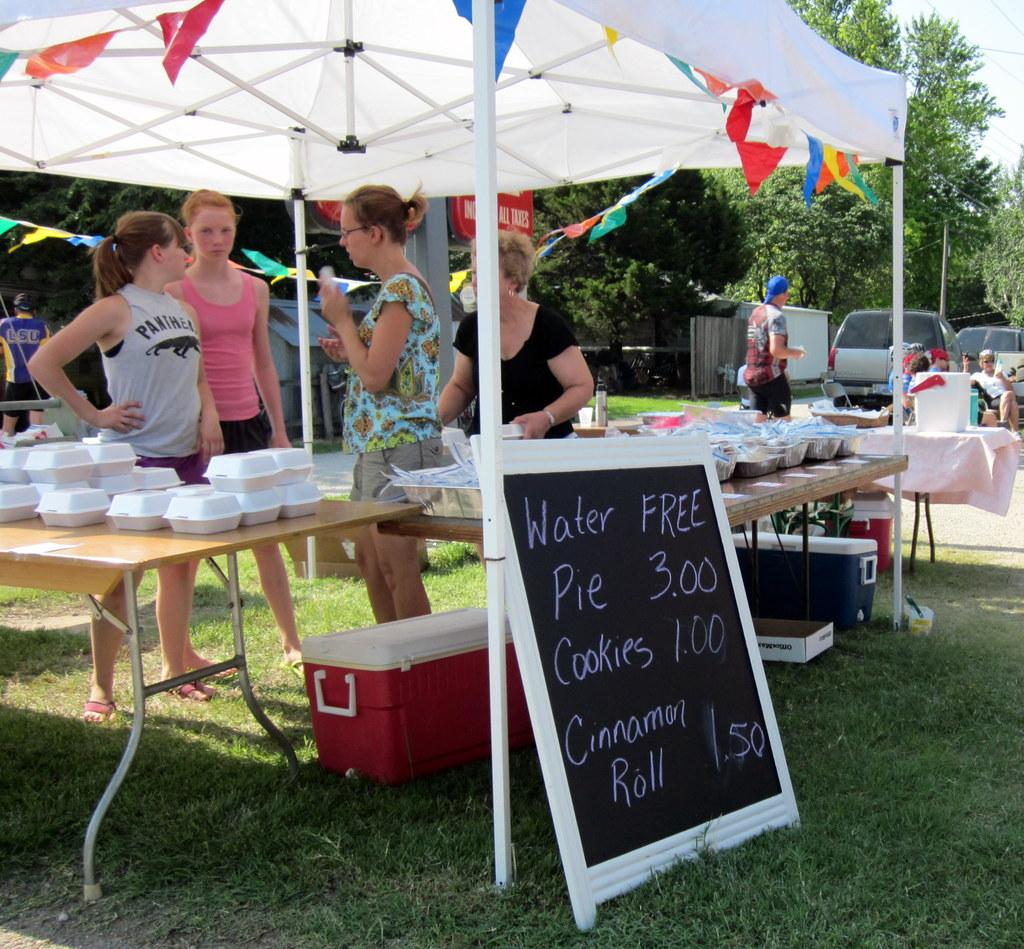How many women are standing beside the table in the image? There are 4 women standing beside the table in the image. Where are the women located in the image? The women are under a tent in the image. What can be seen behind the women? There are people behind the women in the image. What type of natural environment is visible in the image? Trees are visible in the image. What type of man-made objects are present in the image? Vehicles and boxes are visible in the image. What is on the right side of the image? There is a board on the right side of the image. What type of comb is being used by the women in the image? There is no comb visible in the image; the women are not shown using any grooming tools. 